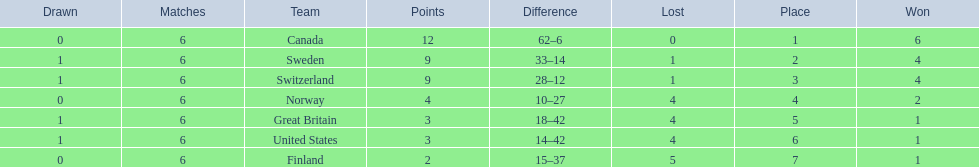What are all the teams? Canada, Sweden, Switzerland, Norway, Great Britain, United States, Finland. What were their points? 12, 9, 9, 4, 3, 3, 2. What about just switzerland and great britain? 9, 3. Now, which of those teams scored higher? Switzerland. 